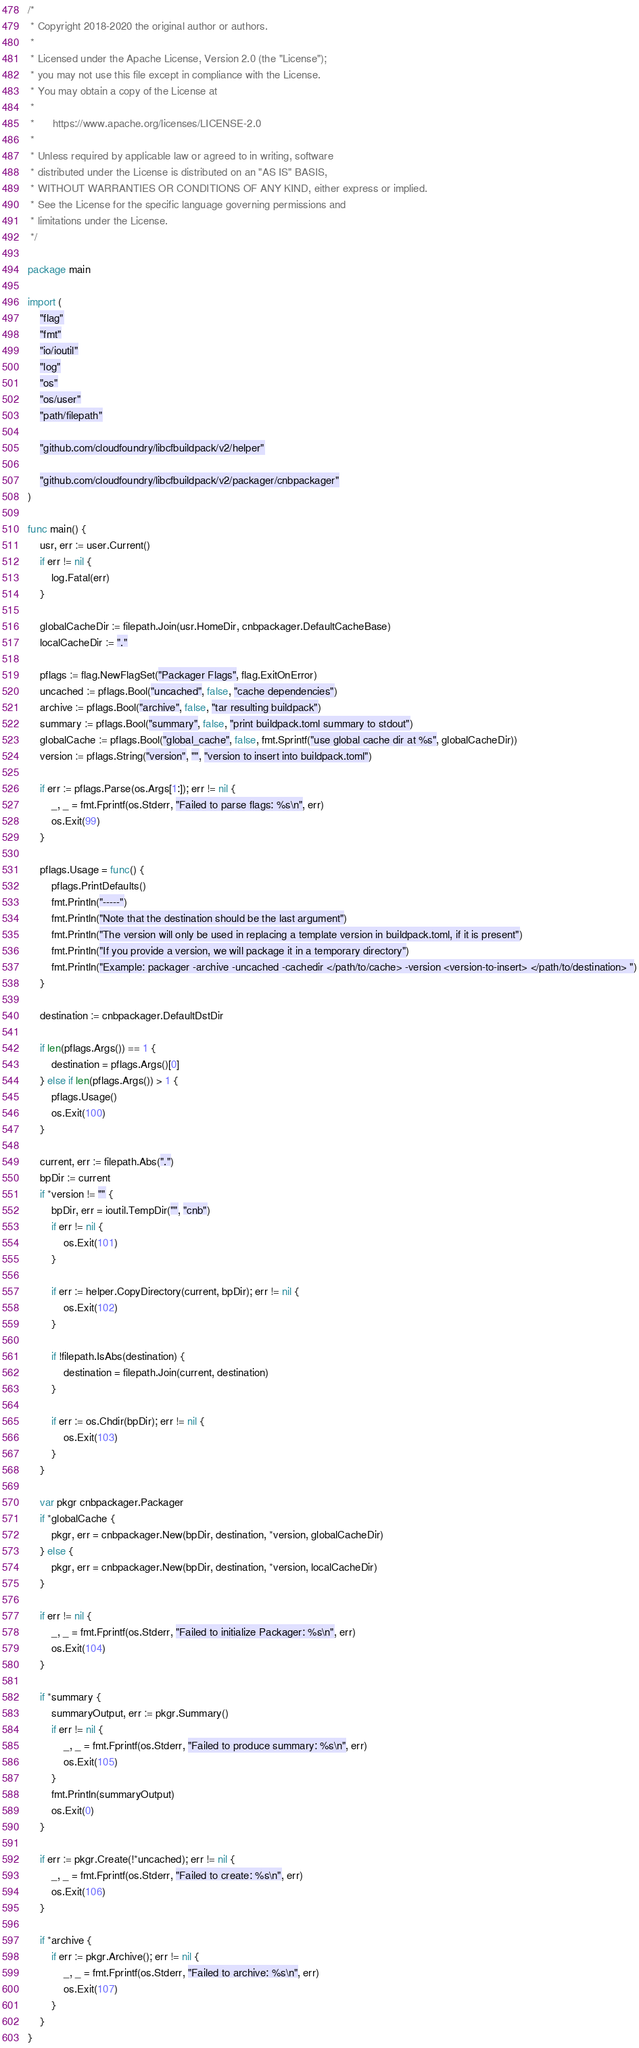Convert code to text. <code><loc_0><loc_0><loc_500><loc_500><_Go_>/*
 * Copyright 2018-2020 the original author or authors.
 *
 * Licensed under the Apache License, Version 2.0 (the "License");
 * you may not use this file except in compliance with the License.
 * You may obtain a copy of the License at
 *
 *      https://www.apache.org/licenses/LICENSE-2.0
 *
 * Unless required by applicable law or agreed to in writing, software
 * distributed under the License is distributed on an "AS IS" BASIS,
 * WITHOUT WARRANTIES OR CONDITIONS OF ANY KIND, either express or implied.
 * See the License for the specific language governing permissions and
 * limitations under the License.
 */

package main

import (
	"flag"
	"fmt"
	"io/ioutil"
	"log"
	"os"
	"os/user"
	"path/filepath"

	"github.com/cloudfoundry/libcfbuildpack/v2/helper"

	"github.com/cloudfoundry/libcfbuildpack/v2/packager/cnbpackager"
)

func main() {
	usr, err := user.Current()
	if err != nil {
		log.Fatal(err)
	}

	globalCacheDir := filepath.Join(usr.HomeDir, cnbpackager.DefaultCacheBase)
	localCacheDir := "."

	pflags := flag.NewFlagSet("Packager Flags", flag.ExitOnError)
	uncached := pflags.Bool("uncached", false, "cache dependencies")
	archive := pflags.Bool("archive", false, "tar resulting buildpack")
	summary := pflags.Bool("summary", false, "print buildpack.toml summary to stdout")
	globalCache := pflags.Bool("global_cache", false, fmt.Sprintf("use global cache dir at %s", globalCacheDir))
	version := pflags.String("version", "", "version to insert into buildpack.toml")

	if err := pflags.Parse(os.Args[1:]); err != nil {
		_, _ = fmt.Fprintf(os.Stderr, "Failed to parse flags: %s\n", err)
		os.Exit(99)
	}

	pflags.Usage = func() {
		pflags.PrintDefaults()
		fmt.Println("-----")
		fmt.Println("Note that the destination should be the last argument")
		fmt.Println("The version will only be used in replacing a template version in buildpack.toml, if it is present")
		fmt.Println("If you provide a version, we will package it in a temporary directory")
		fmt.Println("Example: packager -archive -uncached -cachedir </path/to/cache> -version <version-to-insert> </path/to/destination> ")
	}

	destination := cnbpackager.DefaultDstDir

	if len(pflags.Args()) == 1 {
		destination = pflags.Args()[0]
	} else if len(pflags.Args()) > 1 {
		pflags.Usage()
		os.Exit(100)
	}

	current, err := filepath.Abs(".")
	bpDir := current
	if *version != "" {
		bpDir, err = ioutil.TempDir("", "cnb")
		if err != nil {
			os.Exit(101)
		}

		if err := helper.CopyDirectory(current, bpDir); err != nil {
			os.Exit(102)
		}

		if !filepath.IsAbs(destination) {
			destination = filepath.Join(current, destination)
		}

		if err := os.Chdir(bpDir); err != nil {
			os.Exit(103)
		}
	}

	var pkgr cnbpackager.Packager
	if *globalCache {
		pkgr, err = cnbpackager.New(bpDir, destination, *version, globalCacheDir)
	} else {
		pkgr, err = cnbpackager.New(bpDir, destination, *version, localCacheDir)
	}

	if err != nil {
		_, _ = fmt.Fprintf(os.Stderr, "Failed to initialize Packager: %s\n", err)
		os.Exit(104)
	}

	if *summary {
		summaryOutput, err := pkgr.Summary()
		if err != nil {
			_, _ = fmt.Fprintf(os.Stderr, "Failed to produce summary: %s\n", err)
			os.Exit(105)
		}
		fmt.Println(summaryOutput)
		os.Exit(0)
	}

	if err := pkgr.Create(!*uncached); err != nil {
		_, _ = fmt.Fprintf(os.Stderr, "Failed to create: %s\n", err)
		os.Exit(106)
	}

	if *archive {
		if err := pkgr.Archive(); err != nil {
			_, _ = fmt.Fprintf(os.Stderr, "Failed to archive: %s\n", err)
			os.Exit(107)
		}
	}
}
</code> 